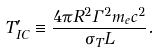<formula> <loc_0><loc_0><loc_500><loc_500>T ^ { \prime } _ { I C } \equiv \frac { 4 \pi R ^ { 2 } \Gamma ^ { 2 } m _ { e } c ^ { 2 } } { \sigma _ { T } L } .</formula> 